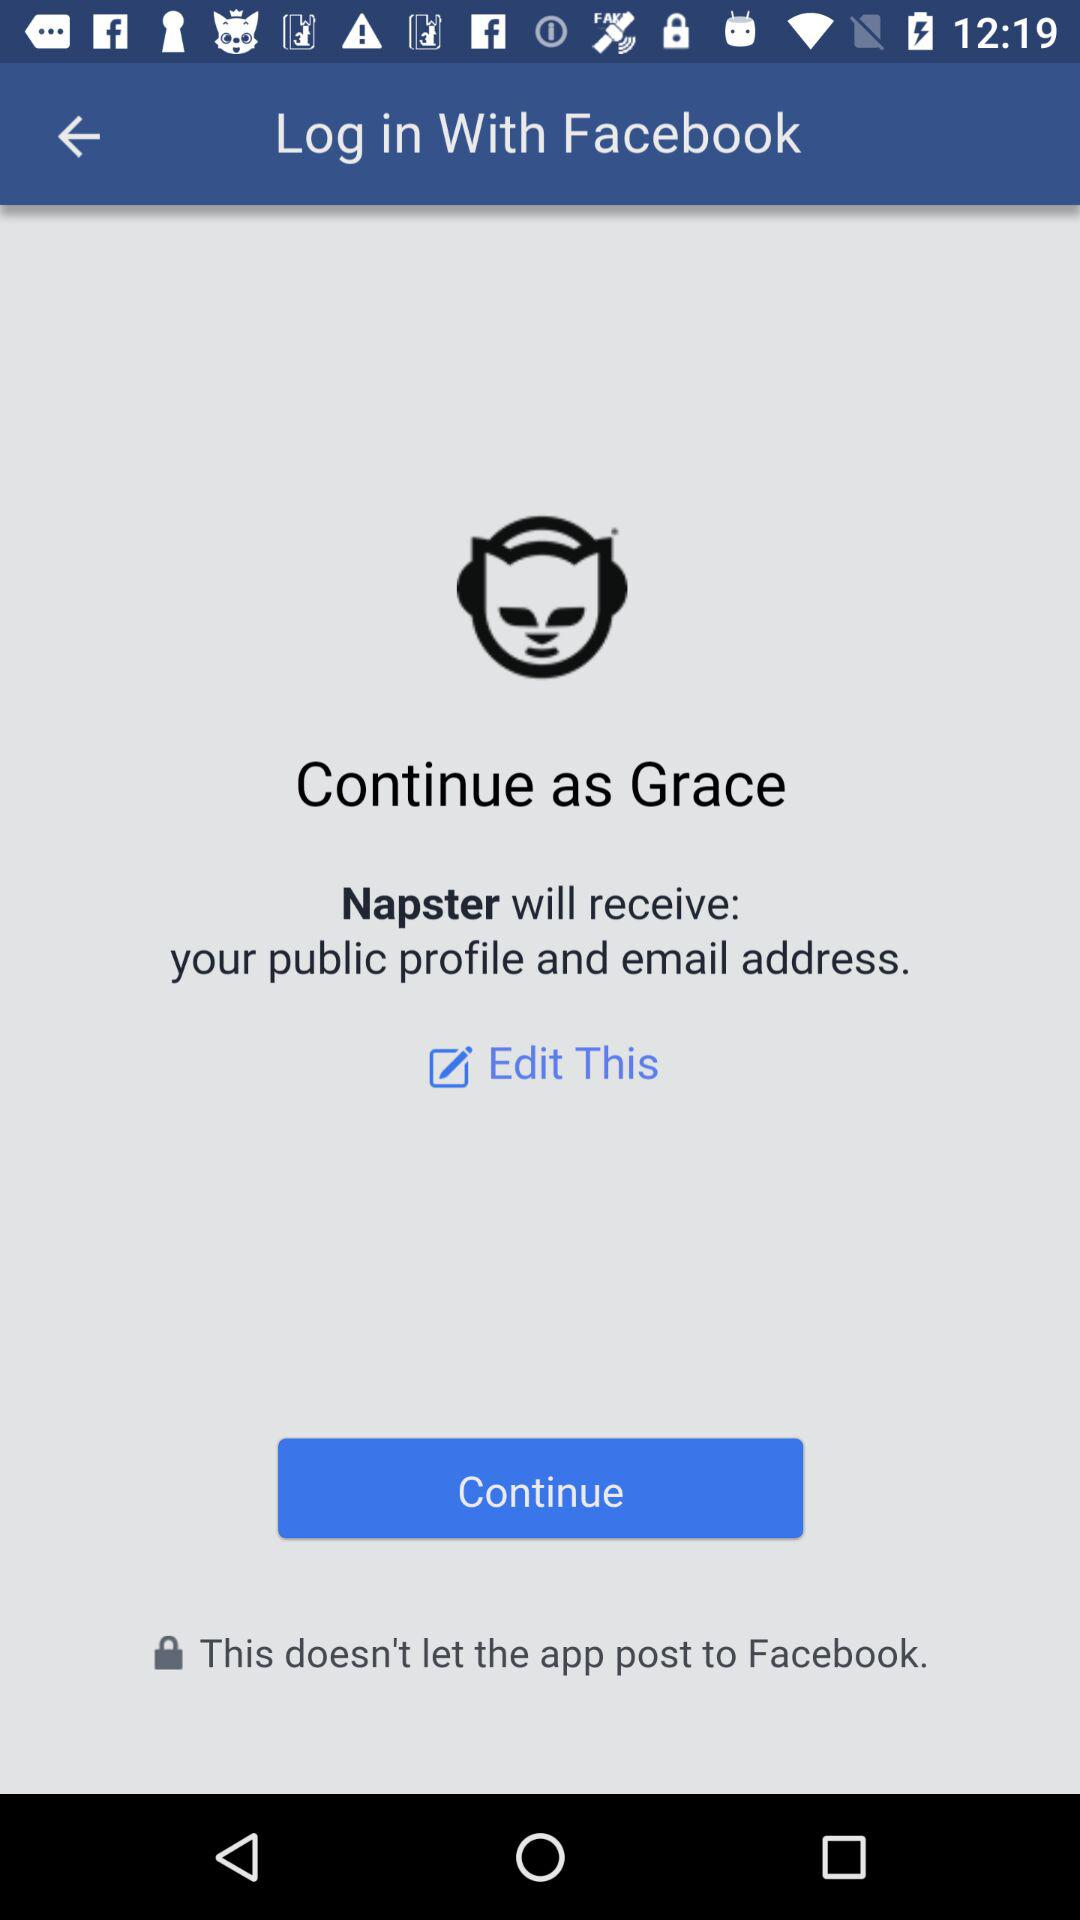What application is asking for permission? The application asking for permission is "Napster". 